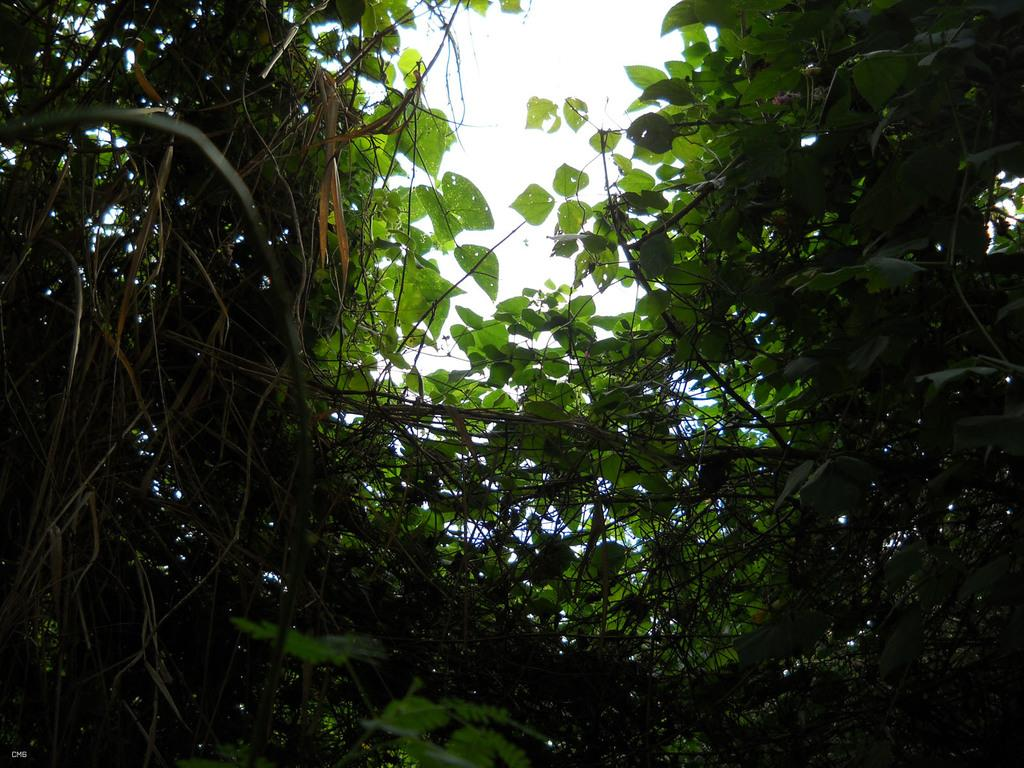What type of vegetation is present in the image? There are creepers with leaves in the image. What can be seen in the background of the image? The sky is visible in the background of the image. How many pets are visible in the image? There are no pets present in the image. What is the direction of the wind in the image? There is no indication of wind in the image, as it only features creepers with leaves and the sky. 